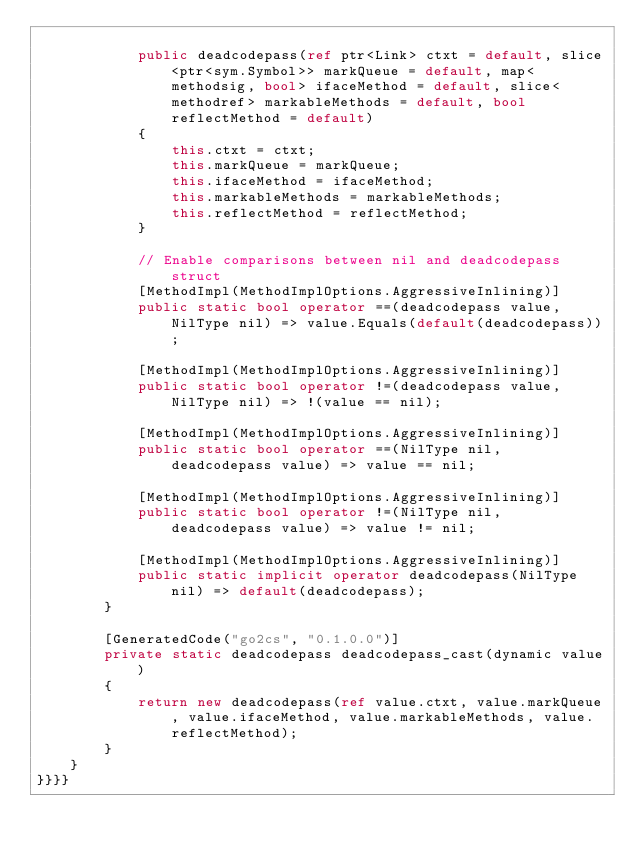Convert code to text. <code><loc_0><loc_0><loc_500><loc_500><_C#_>
            public deadcodepass(ref ptr<Link> ctxt = default, slice<ptr<sym.Symbol>> markQueue = default, map<methodsig, bool> ifaceMethod = default, slice<methodref> markableMethods = default, bool reflectMethod = default)
            {
                this.ctxt = ctxt;
                this.markQueue = markQueue;
                this.ifaceMethod = ifaceMethod;
                this.markableMethods = markableMethods;
                this.reflectMethod = reflectMethod;
            }

            // Enable comparisons between nil and deadcodepass struct
            [MethodImpl(MethodImplOptions.AggressiveInlining)]
            public static bool operator ==(deadcodepass value, NilType nil) => value.Equals(default(deadcodepass));

            [MethodImpl(MethodImplOptions.AggressiveInlining)]
            public static bool operator !=(deadcodepass value, NilType nil) => !(value == nil);

            [MethodImpl(MethodImplOptions.AggressiveInlining)]
            public static bool operator ==(NilType nil, deadcodepass value) => value == nil;

            [MethodImpl(MethodImplOptions.AggressiveInlining)]
            public static bool operator !=(NilType nil, deadcodepass value) => value != nil;

            [MethodImpl(MethodImplOptions.AggressiveInlining)]
            public static implicit operator deadcodepass(NilType nil) => default(deadcodepass);
        }

        [GeneratedCode("go2cs", "0.1.0.0")]
        private static deadcodepass deadcodepass_cast(dynamic value)
        {
            return new deadcodepass(ref value.ctxt, value.markQueue, value.ifaceMethod, value.markableMethods, value.reflectMethod);
        }
    }
}}}}</code> 